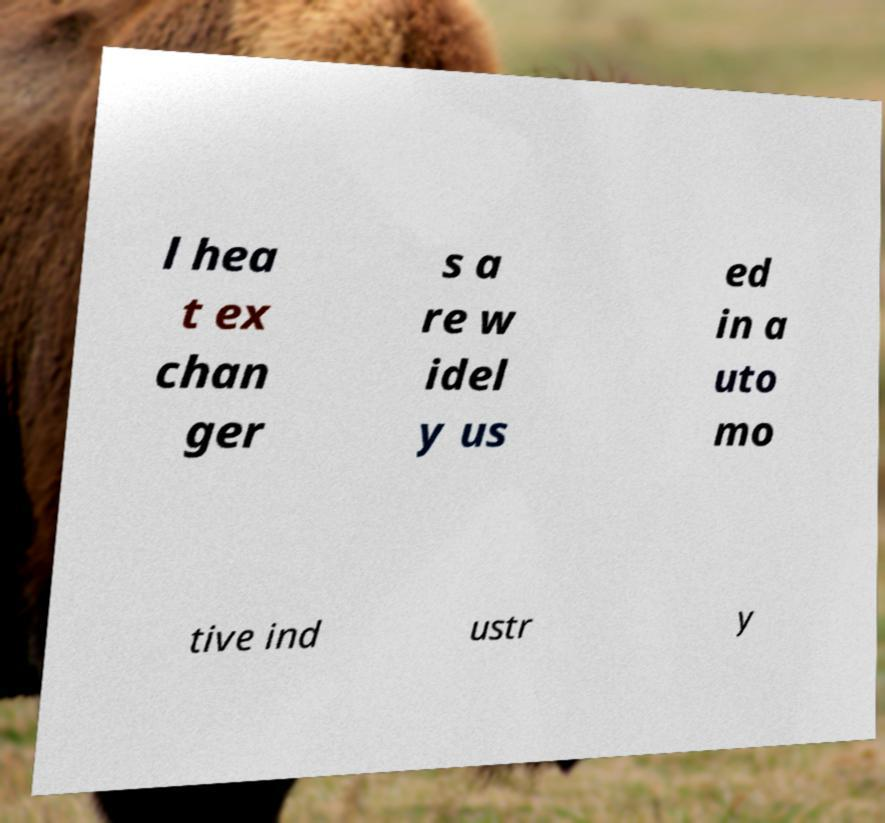Could you extract and type out the text from this image? l hea t ex chan ger s a re w idel y us ed in a uto mo tive ind ustr y 